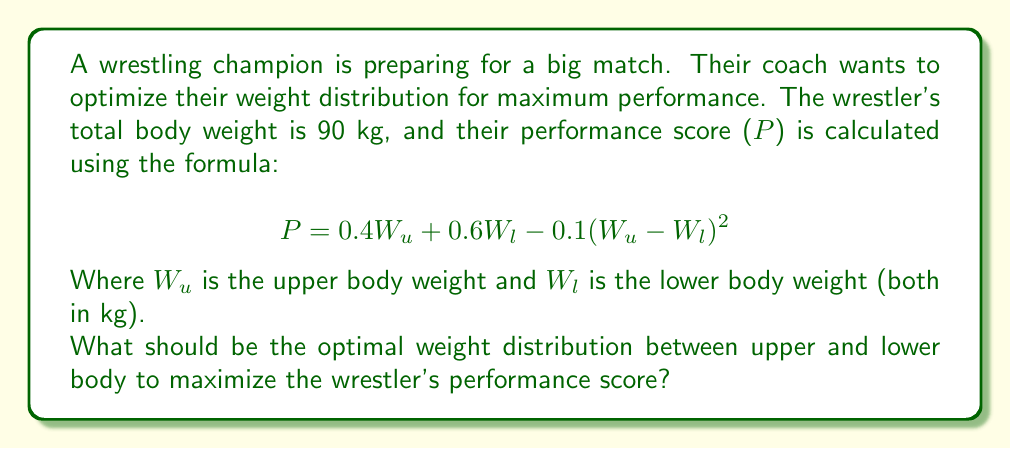Give your solution to this math problem. To solve this optimization problem, we need to follow these steps:

1) First, we know that the total weight is 90 kg, so:

   $W_u + W_l = 90$

2) We can express $W_l$ in terms of $W_u$:

   $W_l = 90 - W_u$

3) Now, let's substitute this into our performance score formula:

   $P = 0.4W_u + 0.6(90 - W_u) - 0.1(W_u - (90 - W_u))^2$

4) Simplify:

   $P = 0.4W_u + 54 - 0.6W_u - 0.1(2W_u - 90)^2$
   $P = 54 - 0.2W_u - 0.1(4W_u^2 - 360W_u + 8100)$
   $P = 54 - 0.2W_u - 0.4W_u^2 + 36W_u - 810$
   $P = -0.4W_u^2 + 35.8W_u - 756$

5) To find the maximum value of P, we need to find where its derivative equals zero:

   $\frac{dP}{dW_u} = -0.8W_u + 35.8 = 0$

6) Solve this equation:

   $-0.8W_u = -35.8$
   $W_u = 44.75$

7) This critical point will give us a maximum (we can confirm this by checking the second derivative is negative).

8) Therefore, the optimal upper body weight is 44.75 kg, and the lower body weight is:

   $W_l = 90 - 44.75 = 45.25$ kg
Answer: The optimal weight distribution is 44.75 kg for the upper body and 45.25 kg for the lower body. 